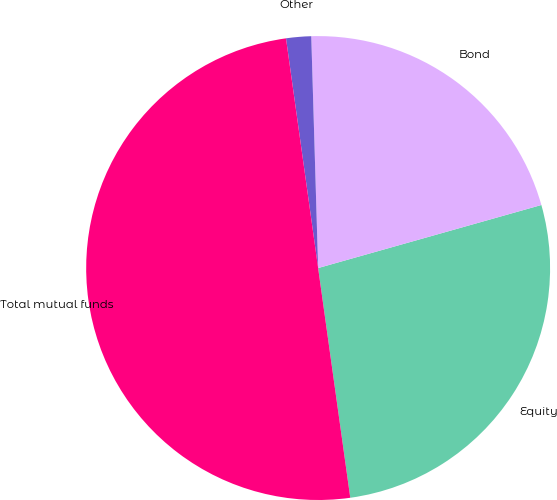Convert chart to OTSL. <chart><loc_0><loc_0><loc_500><loc_500><pie_chart><fcel>Equity<fcel>Bond<fcel>Other<fcel>Total mutual funds<nl><fcel>27.17%<fcel>21.09%<fcel>1.74%<fcel>50.0%<nl></chart> 